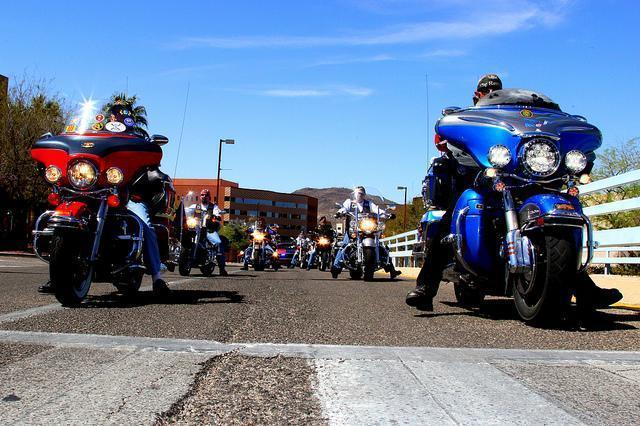How many light poles?
Give a very brief answer. 2. How many red scooters are in the scene?
Give a very brief answer. 1. How many motorcycles are there?
Give a very brief answer. 4. How many people are visible?
Give a very brief answer. 2. 